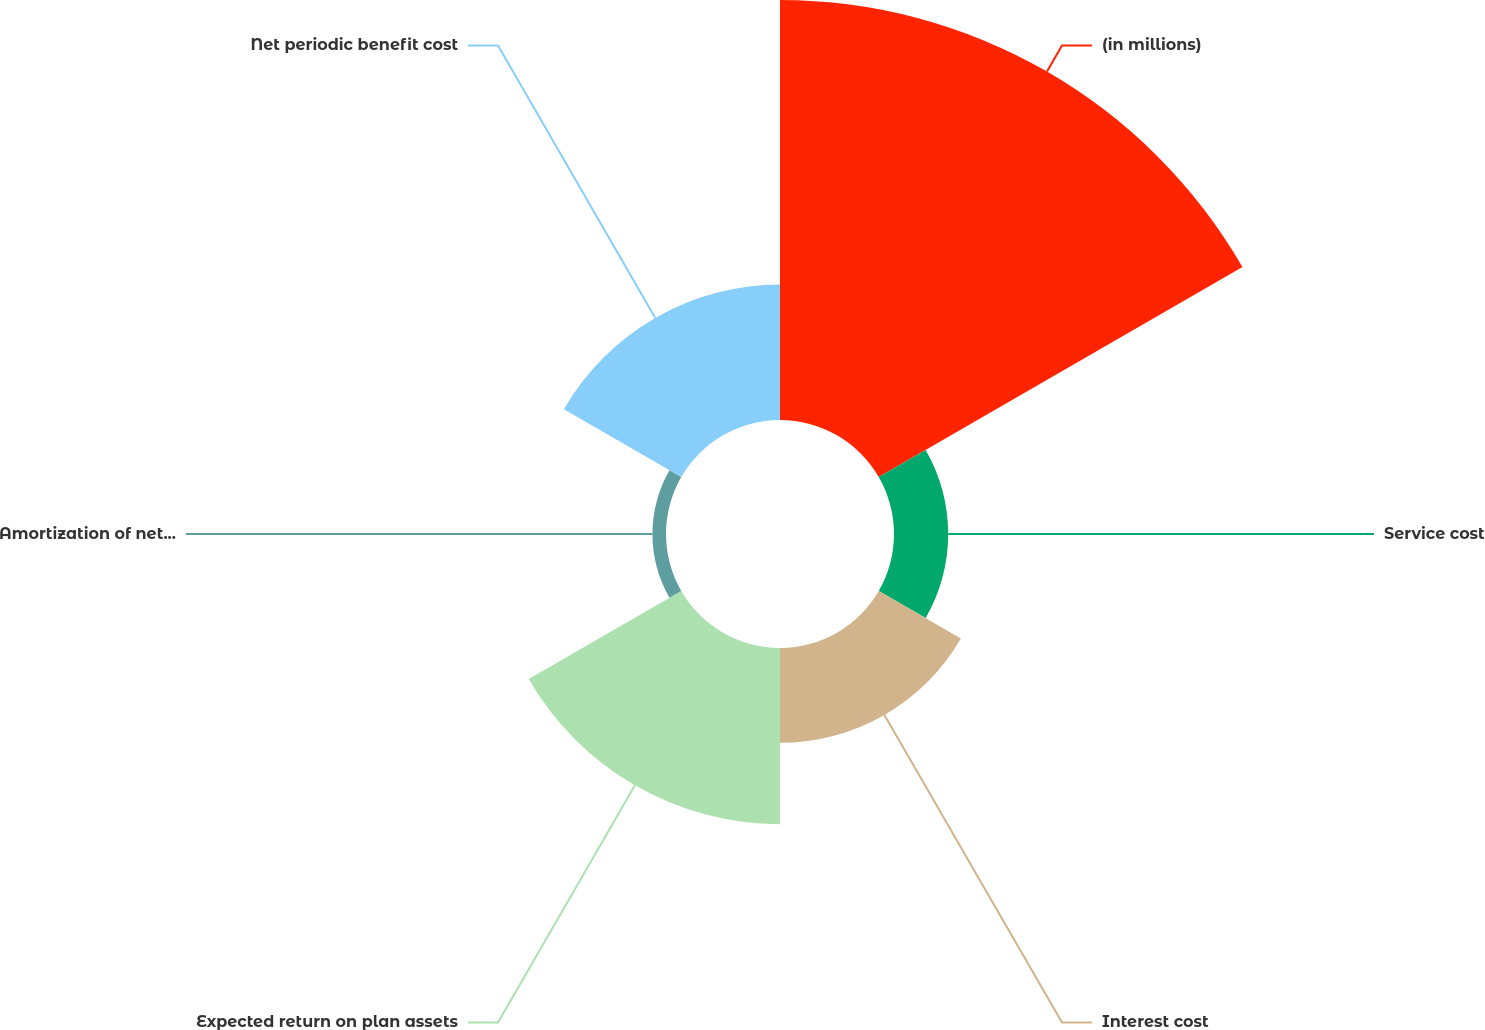Convert chart. <chart><loc_0><loc_0><loc_500><loc_500><pie_chart><fcel>(in millions)<fcel>Service cost<fcel>Interest cost<fcel>Expected return on plan assets<fcel>Amortization of net actuarial<fcel>Net periodic benefit cost<nl><fcel>46.97%<fcel>6.06%<fcel>10.61%<fcel>19.7%<fcel>1.52%<fcel>15.15%<nl></chart> 